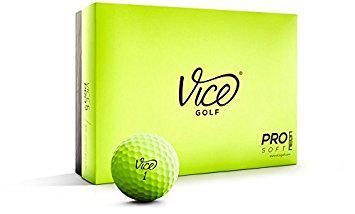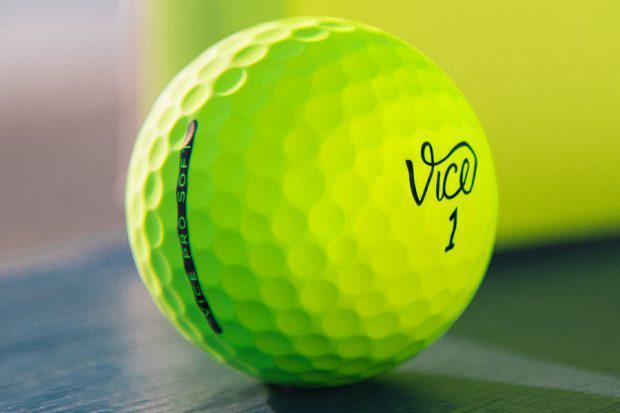The first image is the image on the left, the second image is the image on the right. Analyze the images presented: Is the assertion "Both pictures contain what appear to be the same single golf ball." valid? Answer yes or no. Yes. 